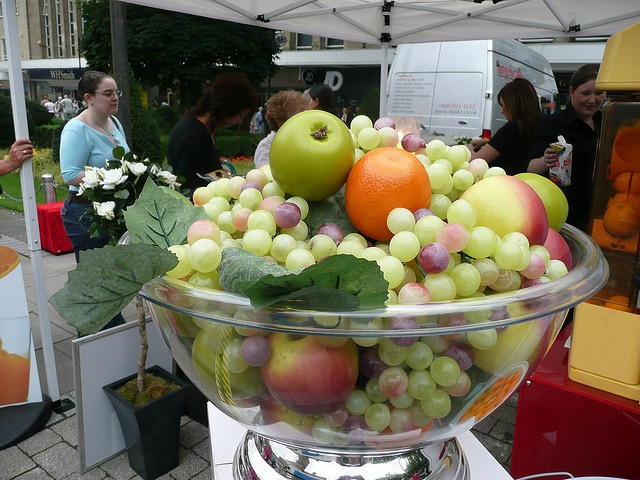Describe the objects in this image and their specific colors. I can see bowl in darkgray, gray, and olive tones, potted plant in darkgray, black, gray, and green tones, truck in darkgray and lightgray tones, apple in darkgray, maroon, brown, and olive tones, and apple in darkgray, olive, and khaki tones in this image. 